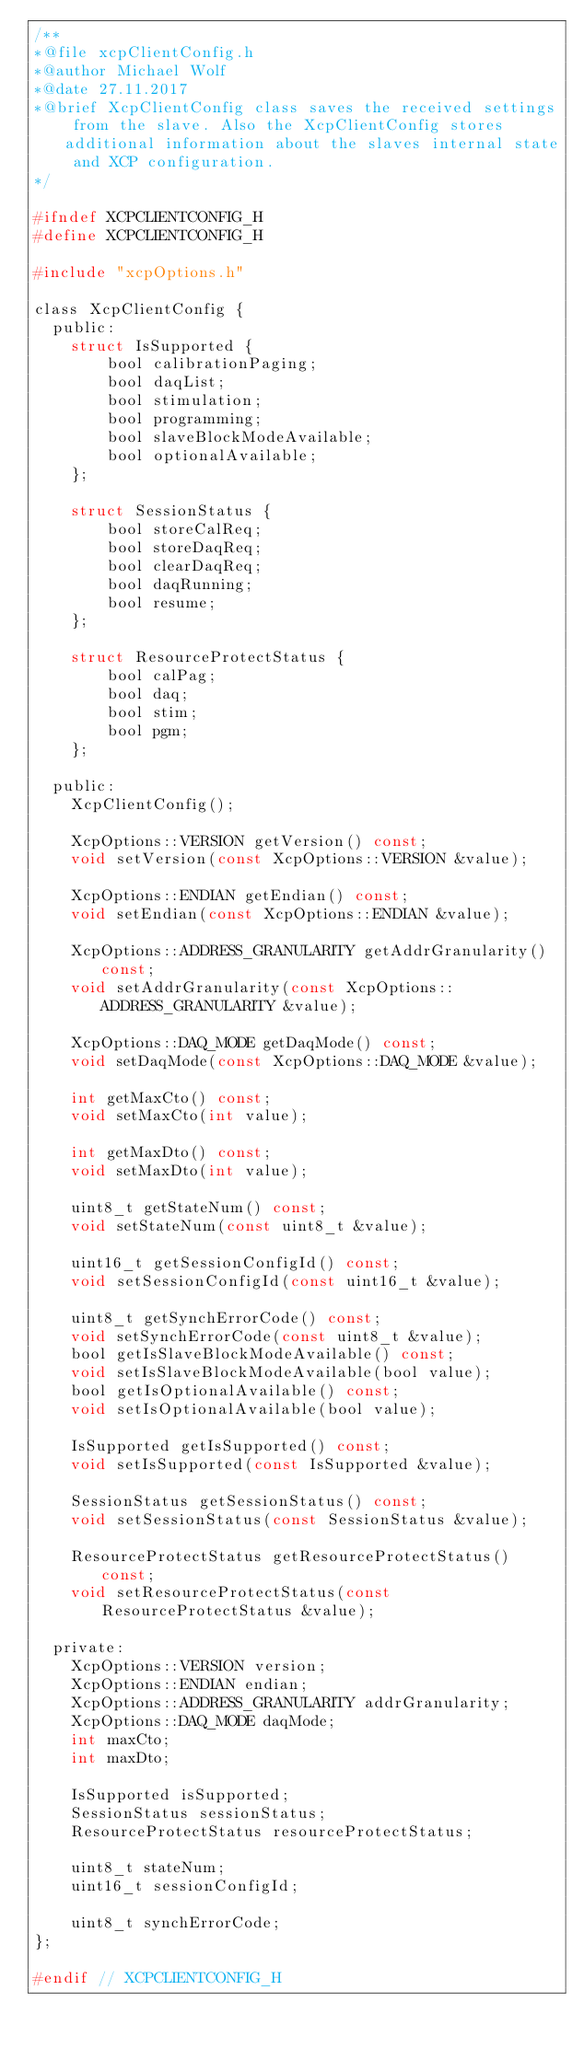<code> <loc_0><loc_0><loc_500><loc_500><_C_>/**
*@file xcpClientConfig.h
*@author Michael Wolf
*@date 27.11.2017
*@brief XcpClientConfig class saves the received settings from the slave. Also the XcpClientConfig stores additional information about the slaves internal state and XCP configuration.
*/

#ifndef XCPCLIENTCONFIG_H
#define XCPCLIENTCONFIG_H

#include "xcpOptions.h"

class XcpClientConfig {
  public:
    struct IsSupported {
        bool calibrationPaging;
        bool daqList;
        bool stimulation;
        bool programming;
        bool slaveBlockModeAvailable;
        bool optionalAvailable;
    };

    struct SessionStatus {
        bool storeCalReq;
        bool storeDaqReq;
        bool clearDaqReq;
        bool daqRunning;
        bool resume;
    };

    struct ResourceProtectStatus {
        bool calPag;
        bool daq;
        bool stim;
        bool pgm;
    };

  public:
    XcpClientConfig();

    XcpOptions::VERSION getVersion() const;
    void setVersion(const XcpOptions::VERSION &value);

    XcpOptions::ENDIAN getEndian() const;
    void setEndian(const XcpOptions::ENDIAN &value);

    XcpOptions::ADDRESS_GRANULARITY getAddrGranularity() const;
    void setAddrGranularity(const XcpOptions::ADDRESS_GRANULARITY &value);

    XcpOptions::DAQ_MODE getDaqMode() const;
    void setDaqMode(const XcpOptions::DAQ_MODE &value);

    int getMaxCto() const;
    void setMaxCto(int value);

    int getMaxDto() const;
    void setMaxDto(int value);

    uint8_t getStateNum() const;
    void setStateNum(const uint8_t &value);

    uint16_t getSessionConfigId() const;
    void setSessionConfigId(const uint16_t &value);

    uint8_t getSynchErrorCode() const;
    void setSynchErrorCode(const uint8_t &value);
    bool getIsSlaveBlockModeAvailable() const;
    void setIsSlaveBlockModeAvailable(bool value);
    bool getIsOptionalAvailable() const;
    void setIsOptionalAvailable(bool value);

    IsSupported getIsSupported() const;
    void setIsSupported(const IsSupported &value);

    SessionStatus getSessionStatus() const;
    void setSessionStatus(const SessionStatus &value);

    ResourceProtectStatus getResourceProtectStatus() const;
    void setResourceProtectStatus(const ResourceProtectStatus &value);

  private:
    XcpOptions::VERSION version;
    XcpOptions::ENDIAN endian;
    XcpOptions::ADDRESS_GRANULARITY addrGranularity;
    XcpOptions::DAQ_MODE daqMode;
    int maxCto;
    int maxDto;

    IsSupported isSupported;
    SessionStatus sessionStatus;
    ResourceProtectStatus resourceProtectStatus;

    uint8_t stateNum;
    uint16_t sessionConfigId;

    uint8_t synchErrorCode;
};

#endif // XCPCLIENTCONFIG_H
</code> 